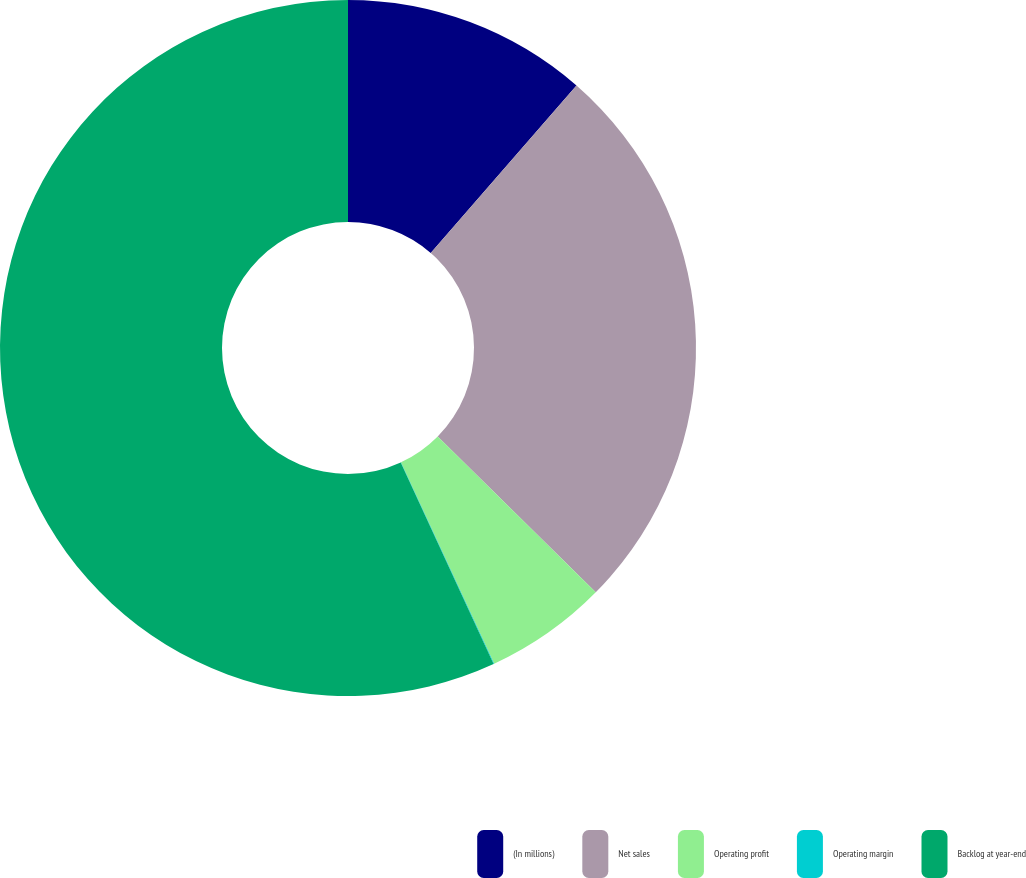Convert chart. <chart><loc_0><loc_0><loc_500><loc_500><pie_chart><fcel>(In millions)<fcel>Net sales<fcel>Operating profit<fcel>Operating margin<fcel>Backlog at year-end<nl><fcel>11.4%<fcel>25.99%<fcel>5.71%<fcel>0.03%<fcel>56.87%<nl></chart> 